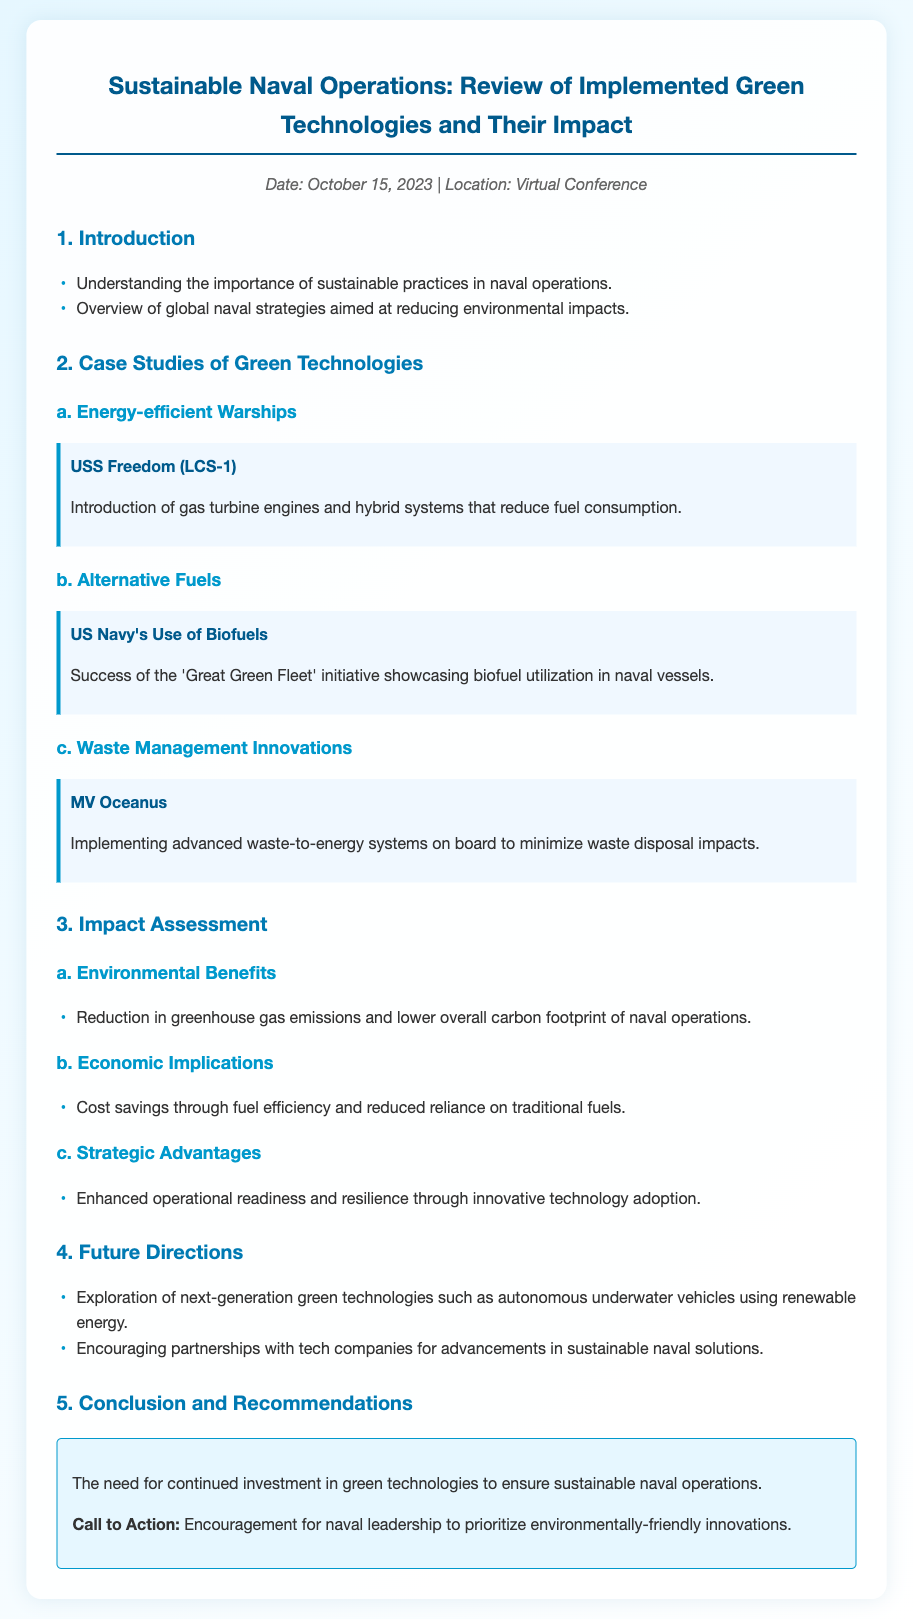What is the date of the virtual conference? The date is mentioned in the meta section of the document.
Answer: October 15, 2023 What is the title of the case study about alternative fuels? The title of the case study is provided under section 2.
Answer: US Navy's Use of Biofuels How does the USS Freedom (LCS-1) reduce fuel consumption? The document describes specific technologies used on the USS Freedom that lead to reduced fuel use.
Answer: Gas turbine engines and hybrid systems What initiative showcases biofuel utilization in naval vessels? The document highlights a particular initiative related to biofuel in naval operations.
Answer: Great Green Fleet What are the economic implications mentioned in the impact assessment? The document lists a specific impact related to cost savings in naval operations.
Answer: Cost savings through fuel efficiency What type of future technologies are being explored according to the agenda? The document discusses specific technologies that are targeted for future exploration and their energy sources.
Answer: Autonomous underwater vehicles using renewable energy What is the main call to action in the conclusion? The conclusion section emphasizes a particular action to be prioritized by naval leadership.
Answer: Prioritize environmentally-friendly innovations 